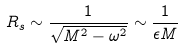Convert formula to latex. <formula><loc_0><loc_0><loc_500><loc_500>R _ { s } \sim \frac { 1 } { \sqrt { M ^ { 2 } - \omega ^ { 2 } } } \sim \frac { 1 } { \epsilon M }</formula> 